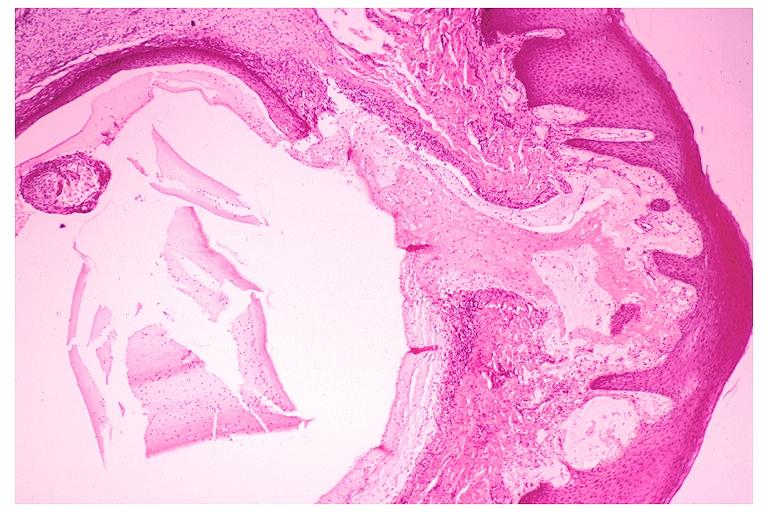where is this?
Answer the question using a single word or phrase. Oral 